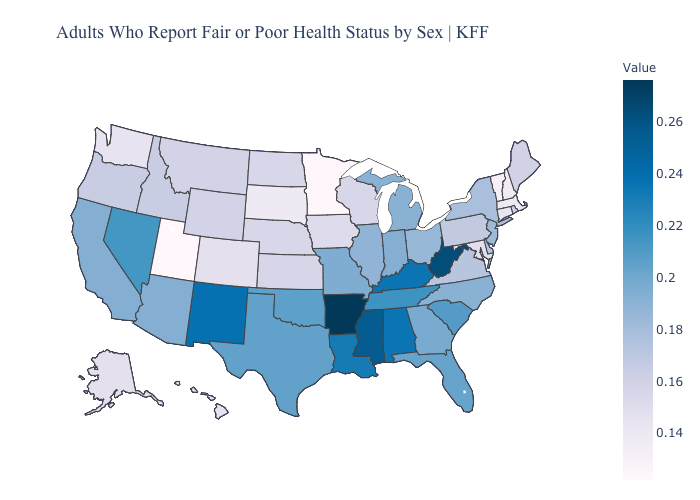Does the map have missing data?
Short answer required. No. Does Arkansas have the highest value in the USA?
Write a very short answer. Yes. Which states have the lowest value in the Northeast?
Answer briefly. Vermont. Among the states that border Maryland , does Delaware have the highest value?
Write a very short answer. No. Which states have the lowest value in the USA?
Keep it brief. Utah. 